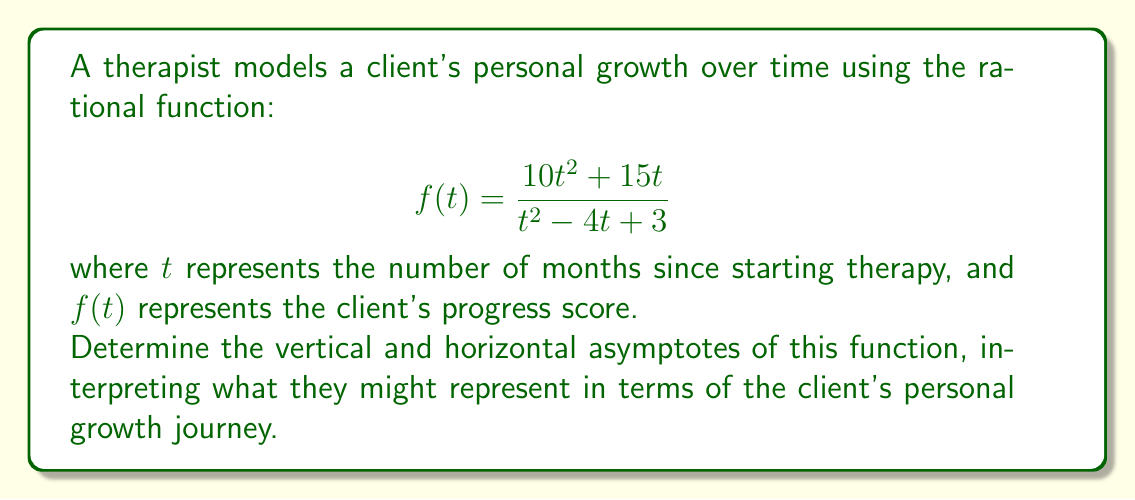Teach me how to tackle this problem. To find the asymptotes, we'll follow these steps:

1. Vertical asymptotes:
   Set the denominator to zero and solve for t:
   $$t^2 - 4t + 3 = 0$$
   $$(t - 1)(t - 3) = 0$$
   $$t = 1 \text{ or } t = 3$$
   
   These represent potential obstacles or milestones in therapy at 1 and 3 months.

2. Horizontal asymptote:
   Compare the degrees of the numerator and denominator:
   Numerator degree: 2
   Denominator degree: 2
   
   Since they're equal, divide the leading coefficients:
   $$\lim_{t \to \infty} \frac{10t^2}{t^2} = 10$$
   
   This suggests a long-term maximum progress score of 10.

3. Slant asymptote:
   Since the degree of the numerator equals the degree of the denominator, there is no slant asymptote.

Interpretation:
- Vertical asymptotes at $t = 1$ and $t = 3$ might represent critical points in therapy where significant breakthroughs or challenges occur.
- The horizontal asymptote at $y = 10$ could represent the maximum potential progress score, suggesting that while growth can continue indefinitely, there's a theoretical limit to measurable progress.
Answer: Vertical asymptotes: $t = 1$, $t = 3$; Horizontal asymptote: $y = 10$ 